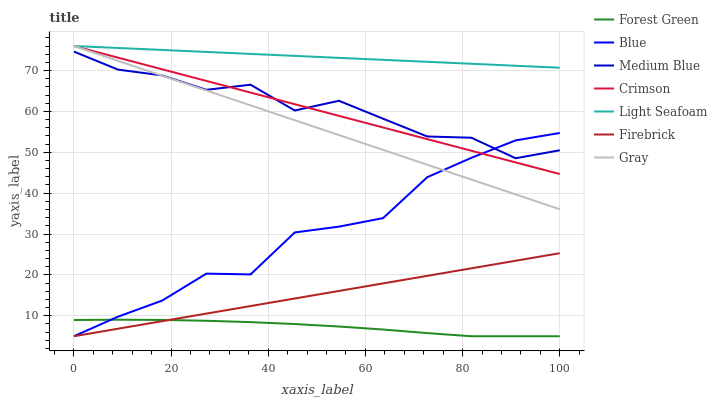Does Forest Green have the minimum area under the curve?
Answer yes or no. Yes. Does Light Seafoam have the maximum area under the curve?
Answer yes or no. Yes. Does Gray have the minimum area under the curve?
Answer yes or no. No. Does Gray have the maximum area under the curve?
Answer yes or no. No. Is Light Seafoam the smoothest?
Answer yes or no. Yes. Is Medium Blue the roughest?
Answer yes or no. Yes. Is Gray the smoothest?
Answer yes or no. No. Is Gray the roughest?
Answer yes or no. No. Does Blue have the lowest value?
Answer yes or no. Yes. Does Gray have the lowest value?
Answer yes or no. No. Does Light Seafoam have the highest value?
Answer yes or no. Yes. Does Firebrick have the highest value?
Answer yes or no. No. Is Firebrick less than Medium Blue?
Answer yes or no. Yes. Is Light Seafoam greater than Blue?
Answer yes or no. Yes. Does Firebrick intersect Forest Green?
Answer yes or no. Yes. Is Firebrick less than Forest Green?
Answer yes or no. No. Is Firebrick greater than Forest Green?
Answer yes or no. No. Does Firebrick intersect Medium Blue?
Answer yes or no. No. 